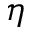<formula> <loc_0><loc_0><loc_500><loc_500>\eta</formula> 